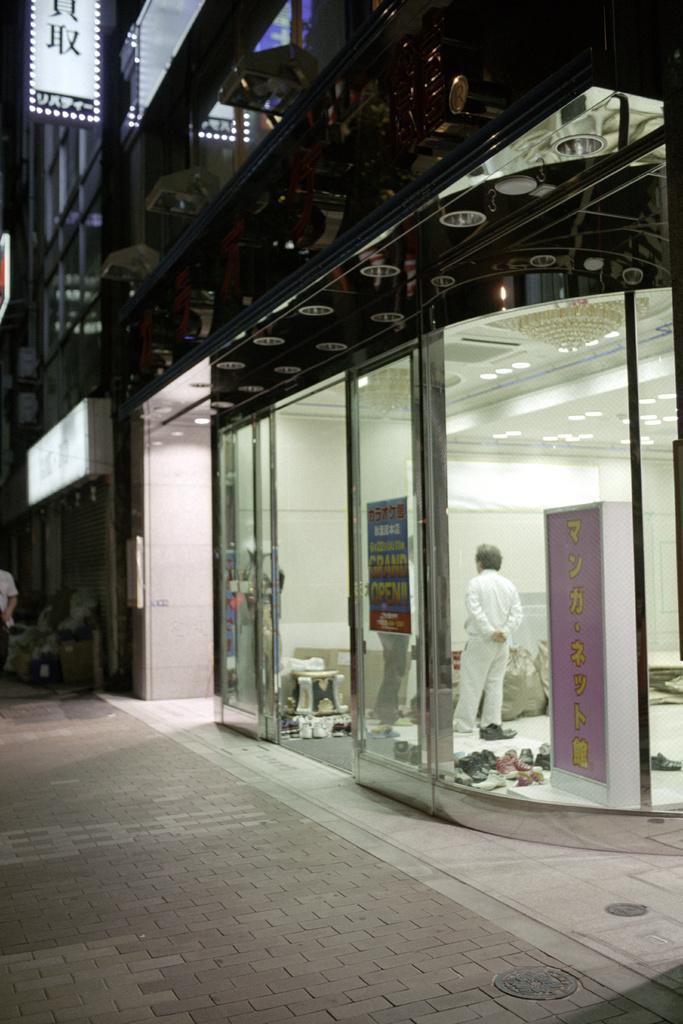Describe this image in one or two sentences. In this picture I can see two persons standing inside a shop, there are chandeliers, lights, there are some objects on the floor, there are boards and there are buildings. 